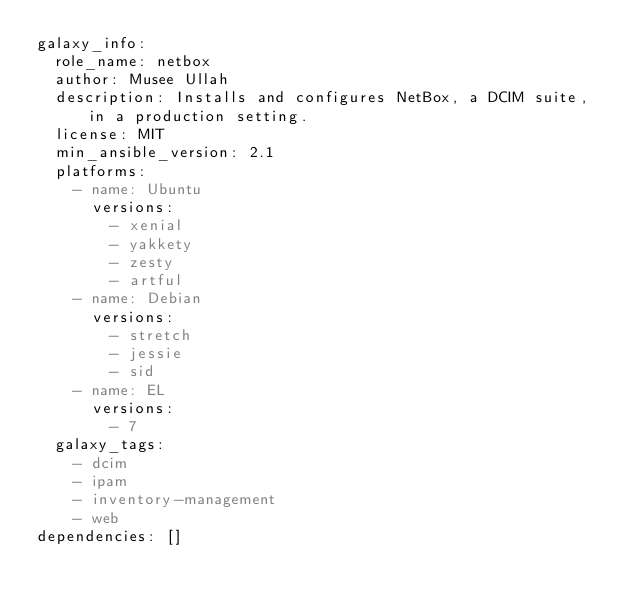Convert code to text. <code><loc_0><loc_0><loc_500><loc_500><_YAML_>galaxy_info:
  role_name: netbox
  author: Musee Ullah
  description: Installs and configures NetBox, a DCIM suite, in a production setting.
  license: MIT
  min_ansible_version: 2.1
  platforms:
    - name: Ubuntu
      versions:
        - xenial
        - yakkety
        - zesty
        - artful
    - name: Debian
      versions:
        - stretch
        - jessie
        - sid
    - name: EL
      versions:
        - 7
  galaxy_tags:
    - dcim
    - ipam
    - inventory-management
    - web
dependencies: []
</code> 